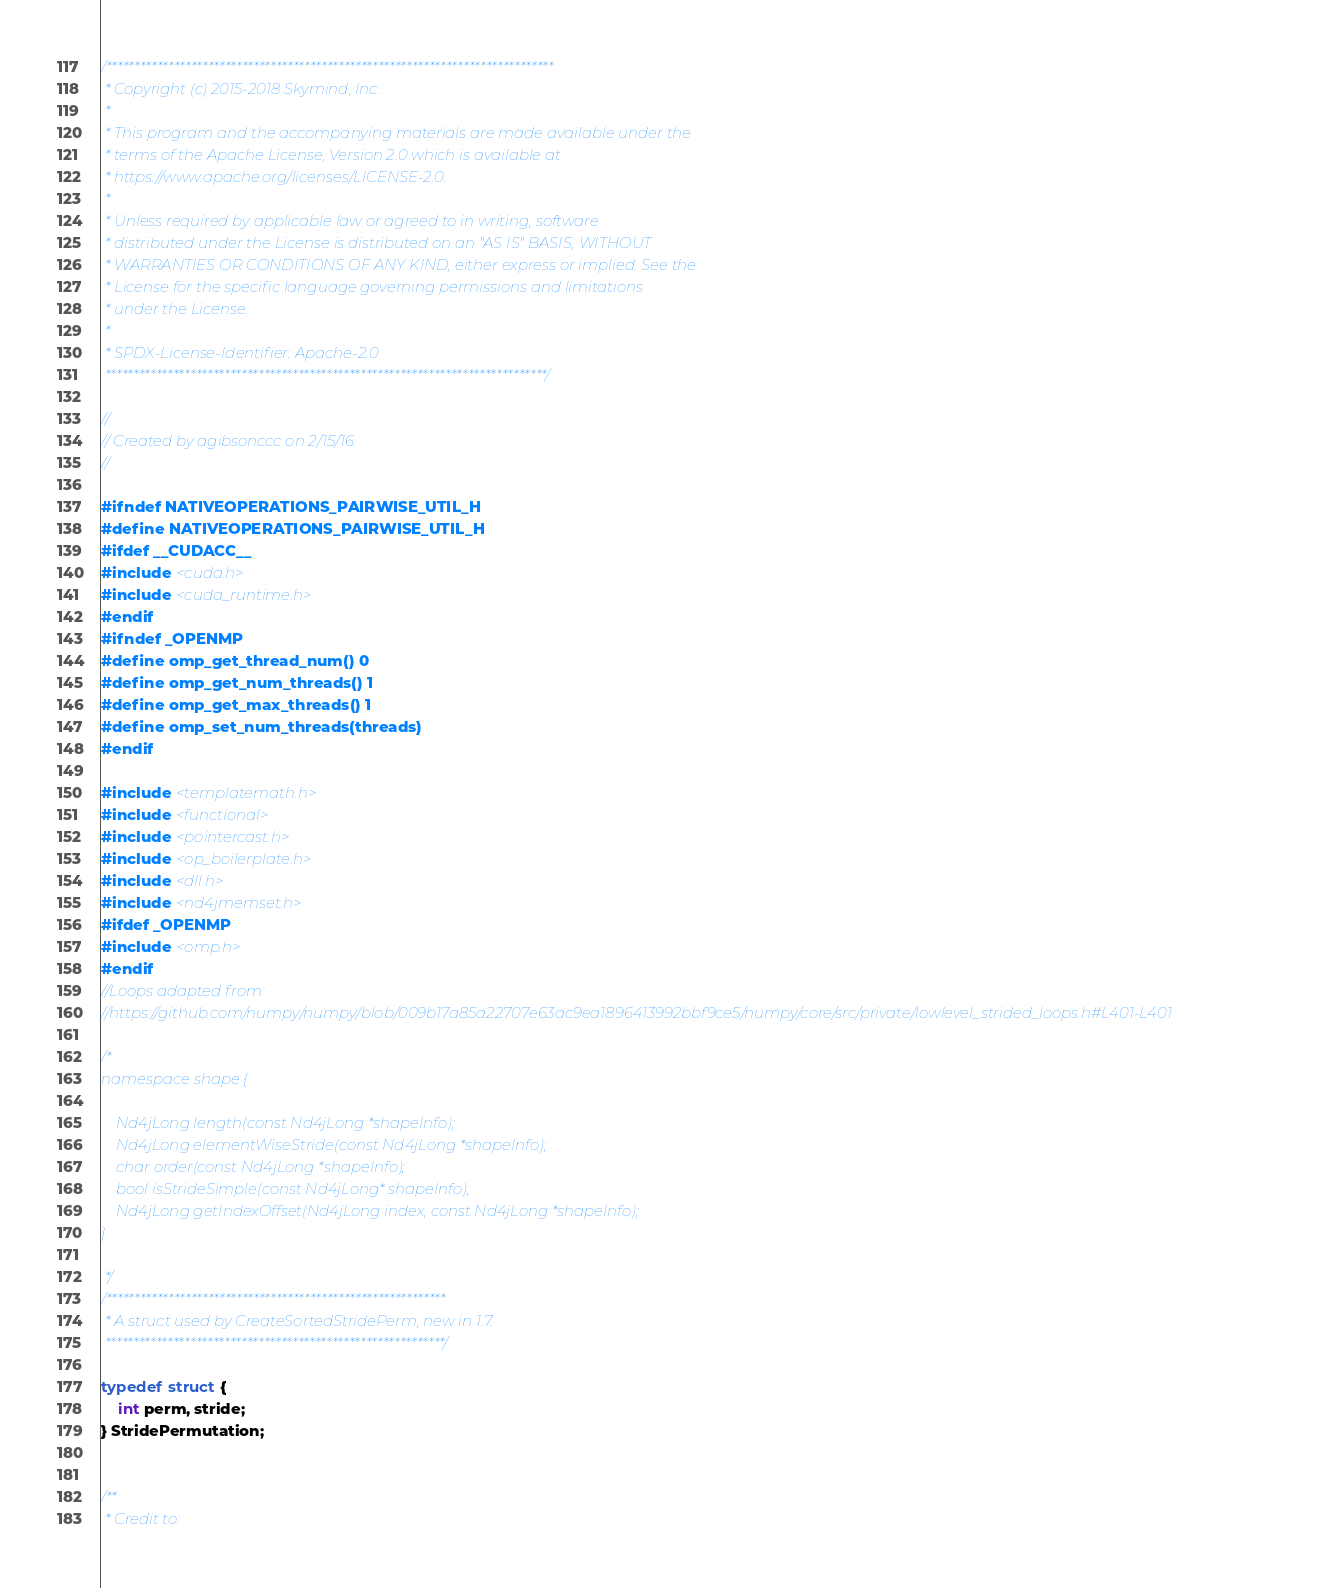Convert code to text. <code><loc_0><loc_0><loc_500><loc_500><_C_>/*******************************************************************************
 * Copyright (c) 2015-2018 Skymind, Inc.
 *
 * This program and the accompanying materials are made available under the
 * terms of the Apache License, Version 2.0 which is available at
 * https://www.apache.org/licenses/LICENSE-2.0.
 *
 * Unless required by applicable law or agreed to in writing, software
 * distributed under the License is distributed on an "AS IS" BASIS, WITHOUT
 * WARRANTIES OR CONDITIONS OF ANY KIND, either express or implied. See the
 * License for the specific language governing permissions and limitations
 * under the License.
 *
 * SPDX-License-Identifier: Apache-2.0
 ******************************************************************************/

//
// Created by agibsonccc on 2/15/16.
//

#ifndef NATIVEOPERATIONS_PAIRWISE_UTIL_H
#define NATIVEOPERATIONS_PAIRWISE_UTIL_H
#ifdef __CUDACC__
#include <cuda.h>
#include <cuda_runtime.h>
#endif
#ifndef _OPENMP
#define omp_get_thread_num() 0
#define omp_get_num_threads() 1
#define omp_get_max_threads() 1
#define omp_set_num_threads(threads)
#endif

#include <templatemath.h>
#include <functional>
#include <pointercast.h>
#include <op_boilerplate.h>
#include <dll.h>
#include <nd4jmemset.h>
#ifdef _OPENMP
#include <omp.h>
#endif
//Loops adapted from:
//https://github.com/numpy/numpy/blob/009b17a85a22707e63ac9ea1896413992bbf9ce5/numpy/core/src/private/lowlevel_strided_loops.h#L401-L401

/*
namespace shape {

    Nd4jLong length(const Nd4jLong *shapeInfo);
    Nd4jLong elementWiseStride(const Nd4jLong *shapeInfo);
    char order(const Nd4jLong *shapeInfo);
    bool isStrideSimple(const Nd4jLong* shapeInfo);
    Nd4jLong getIndexOffset(Nd4jLong index, const Nd4jLong *shapeInfo);
}

 */
/************************************************************
 * A struct used by CreateSortedStridePerm, new in 1.7.
 ************************************************************/

typedef struct {
    int perm, stride;
} StridePermutation;


/**
 * Credit to:</code> 